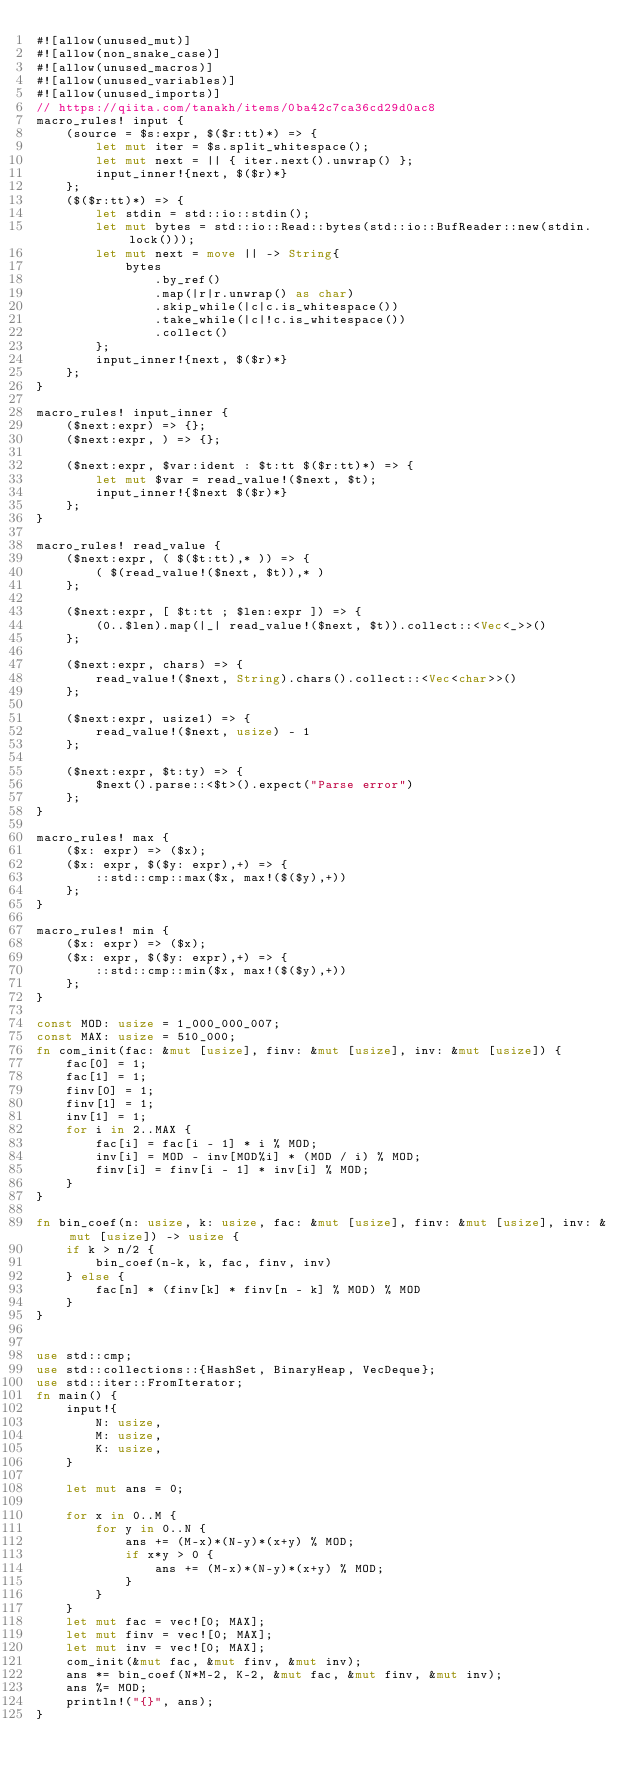Convert code to text. <code><loc_0><loc_0><loc_500><loc_500><_Rust_>#![allow(unused_mut)]
#![allow(non_snake_case)]
#![allow(unused_macros)]
#![allow(unused_variables)]
#![allow(unused_imports)]
// https://qiita.com/tanakh/items/0ba42c7ca36cd29d0ac8
macro_rules! input {
    (source = $s:expr, $($r:tt)*) => {
        let mut iter = $s.split_whitespace();
        let mut next = || { iter.next().unwrap() };
        input_inner!{next, $($r)*}
    };
    ($($r:tt)*) => {
        let stdin = std::io::stdin();
        let mut bytes = std::io::Read::bytes(std::io::BufReader::new(stdin.lock()));
        let mut next = move || -> String{
            bytes
                .by_ref()
                .map(|r|r.unwrap() as char)
                .skip_while(|c|c.is_whitespace())
                .take_while(|c|!c.is_whitespace())
                .collect()
        };
        input_inner!{next, $($r)*}
    };
}

macro_rules! input_inner {
    ($next:expr) => {};
    ($next:expr, ) => {};

    ($next:expr, $var:ident : $t:tt $($r:tt)*) => {
        let mut $var = read_value!($next, $t);
        input_inner!{$next $($r)*}
    };
}

macro_rules! read_value {
    ($next:expr, ( $($t:tt),* )) => {
        ( $(read_value!($next, $t)),* )
    };

    ($next:expr, [ $t:tt ; $len:expr ]) => {
        (0..$len).map(|_| read_value!($next, $t)).collect::<Vec<_>>()
    };

    ($next:expr, chars) => {
        read_value!($next, String).chars().collect::<Vec<char>>()
    };

    ($next:expr, usize1) => {
        read_value!($next, usize) - 1
    };

    ($next:expr, $t:ty) => {
        $next().parse::<$t>().expect("Parse error")
    };
}

macro_rules! max {
    ($x: expr) => ($x);
    ($x: expr, $($y: expr),+) => {
        ::std::cmp::max($x, max!($($y),+))
    };
}

macro_rules! min {
    ($x: expr) => ($x);
    ($x: expr, $($y: expr),+) => {
        ::std::cmp::min($x, max!($($y),+))
    };
}

const MOD: usize = 1_000_000_007;
const MAX: usize = 510_000;
fn com_init(fac: &mut [usize], finv: &mut [usize], inv: &mut [usize]) {
    fac[0] = 1;
    fac[1] = 1;
    finv[0] = 1;
    finv[1] = 1;
    inv[1] = 1;
    for i in 2..MAX {
        fac[i] = fac[i - 1] * i % MOD;
        inv[i] = MOD - inv[MOD%i] * (MOD / i) % MOD;
        finv[i] = finv[i - 1] * inv[i] % MOD;
    }
}

fn bin_coef(n: usize, k: usize, fac: &mut [usize], finv: &mut [usize], inv: &mut [usize]) -> usize {
    if k > n/2 {
        bin_coef(n-k, k, fac, finv, inv)
    } else {
        fac[n] * (finv[k] * finv[n - k] % MOD) % MOD
    }
}


use std::cmp;
use std::collections::{HashSet, BinaryHeap, VecDeque};
use std::iter::FromIterator;
fn main() {
    input!{
        N: usize,
        M: usize,
        K: usize,
    }

    let mut ans = 0;

    for x in 0..M {
        for y in 0..N {
            ans += (M-x)*(N-y)*(x+y) % MOD;
            if x*y > 0 {
                ans += (M-x)*(N-y)*(x+y) % MOD;
            }
        }
    }
    let mut fac = vec![0; MAX];
    let mut finv = vec![0; MAX];
    let mut inv = vec![0; MAX];
    com_init(&mut fac, &mut finv, &mut inv);
    ans *= bin_coef(N*M-2, K-2, &mut fac, &mut finv, &mut inv);
    ans %= MOD;
    println!("{}", ans);
}
</code> 